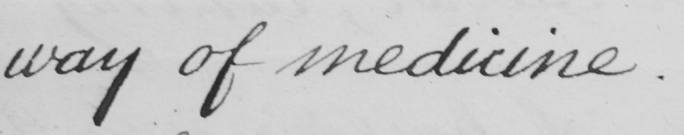Please provide the text content of this handwritten line. way of medicine. 